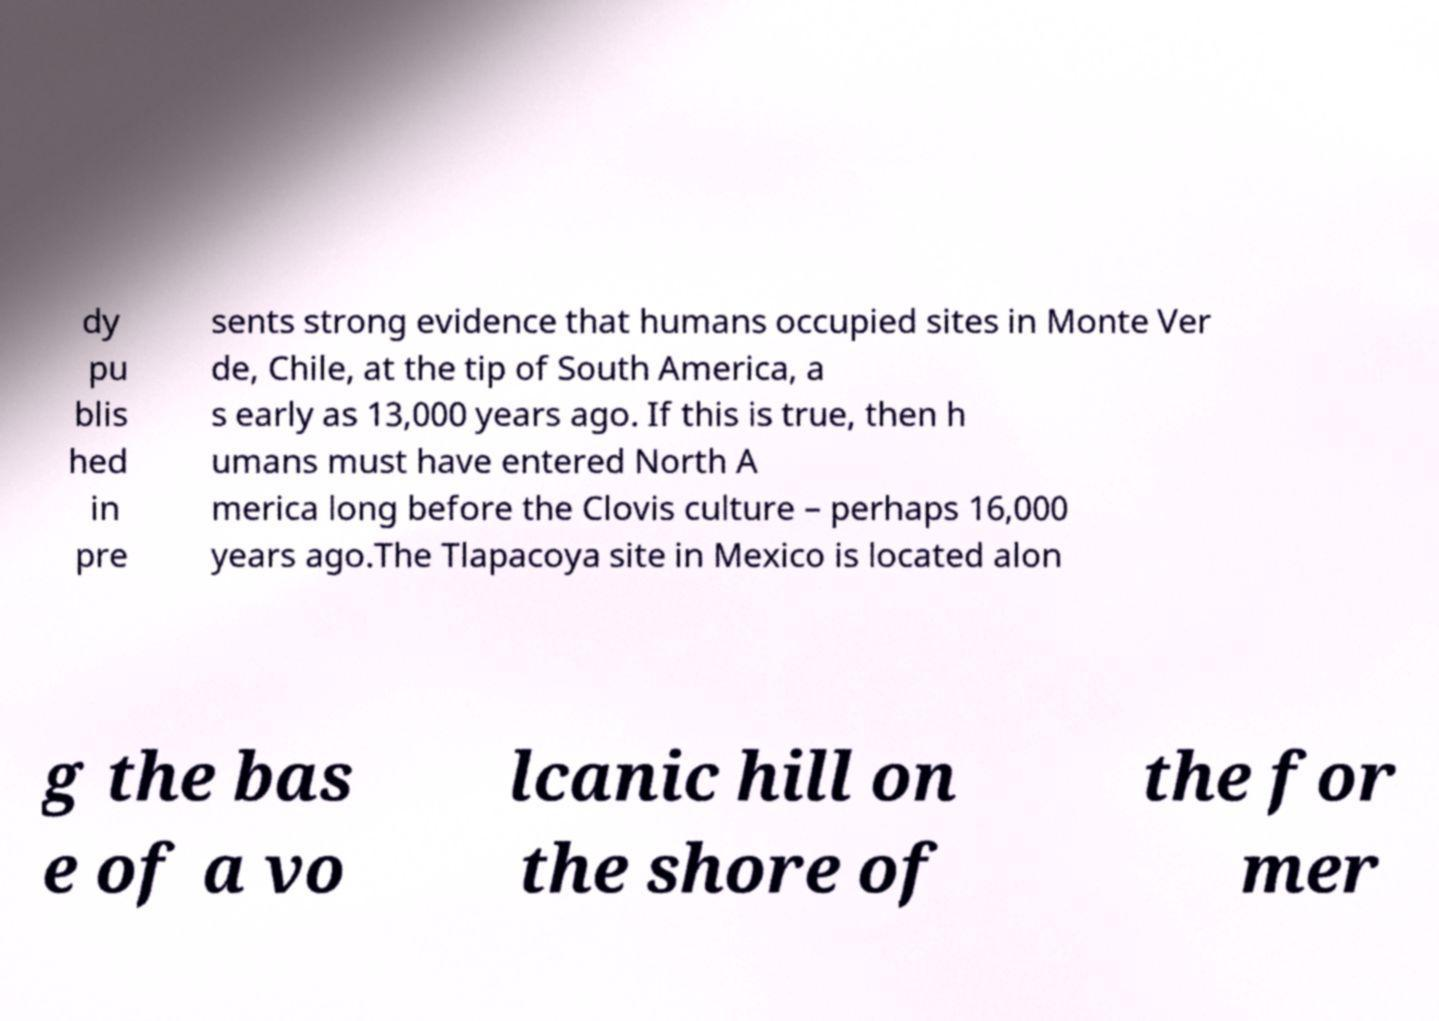What messages or text are displayed in this image? I need them in a readable, typed format. dy pu blis hed in pre sents strong evidence that humans occupied sites in Monte Ver de, Chile, at the tip of South America, a s early as 13,000 years ago. If this is true, then h umans must have entered North A merica long before the Clovis culture – perhaps 16,000 years ago.The Tlapacoya site in Mexico is located alon g the bas e of a vo lcanic hill on the shore of the for mer 